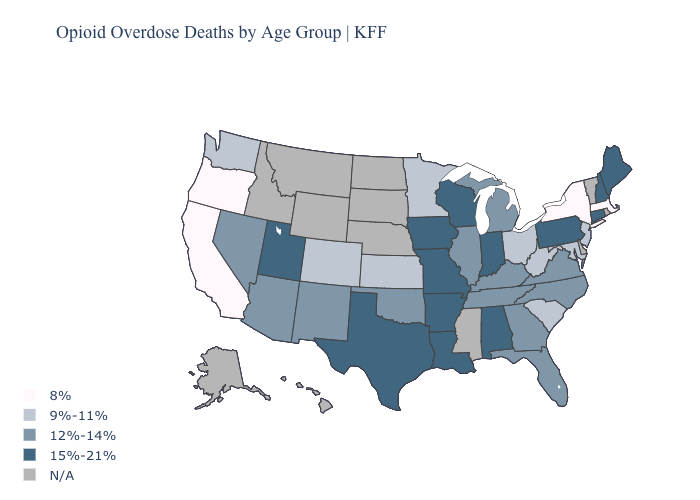What is the value of Iowa?
Be succinct. 15%-21%. Does the map have missing data?
Answer briefly. Yes. Name the states that have a value in the range 12%-14%?
Quick response, please. Arizona, Florida, Georgia, Illinois, Kentucky, Michigan, Nevada, New Mexico, North Carolina, Oklahoma, Tennessee, Virginia. Which states hav the highest value in the South?
Quick response, please. Alabama, Arkansas, Louisiana, Texas. Name the states that have a value in the range N/A?
Write a very short answer. Alaska, Delaware, Hawaii, Idaho, Mississippi, Montana, Nebraska, North Dakota, Rhode Island, South Dakota, Vermont, Wyoming. Which states have the lowest value in the South?
Write a very short answer. Maryland, South Carolina, West Virginia. Which states have the lowest value in the USA?
Concise answer only. California, Massachusetts, New York, Oregon. Name the states that have a value in the range 8%?
Write a very short answer. California, Massachusetts, New York, Oregon. What is the highest value in states that border California?
Write a very short answer. 12%-14%. Name the states that have a value in the range 12%-14%?
Keep it brief. Arizona, Florida, Georgia, Illinois, Kentucky, Michigan, Nevada, New Mexico, North Carolina, Oklahoma, Tennessee, Virginia. Does New York have the highest value in the USA?
Concise answer only. No. Does the map have missing data?
Write a very short answer. Yes. What is the lowest value in states that border Indiana?
Short answer required. 9%-11%. Which states have the lowest value in the USA?
Quick response, please. California, Massachusetts, New York, Oregon. What is the value of Connecticut?
Short answer required. 15%-21%. 